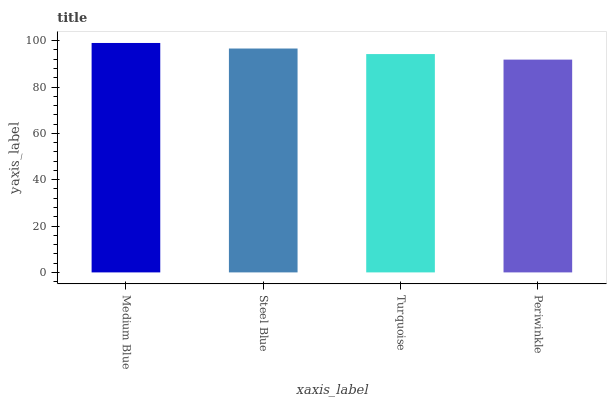Is Periwinkle the minimum?
Answer yes or no. Yes. Is Medium Blue the maximum?
Answer yes or no. Yes. Is Steel Blue the minimum?
Answer yes or no. No. Is Steel Blue the maximum?
Answer yes or no. No. Is Medium Blue greater than Steel Blue?
Answer yes or no. Yes. Is Steel Blue less than Medium Blue?
Answer yes or no. Yes. Is Steel Blue greater than Medium Blue?
Answer yes or no. No. Is Medium Blue less than Steel Blue?
Answer yes or no. No. Is Steel Blue the high median?
Answer yes or no. Yes. Is Turquoise the low median?
Answer yes or no. Yes. Is Periwinkle the high median?
Answer yes or no. No. Is Steel Blue the low median?
Answer yes or no. No. 